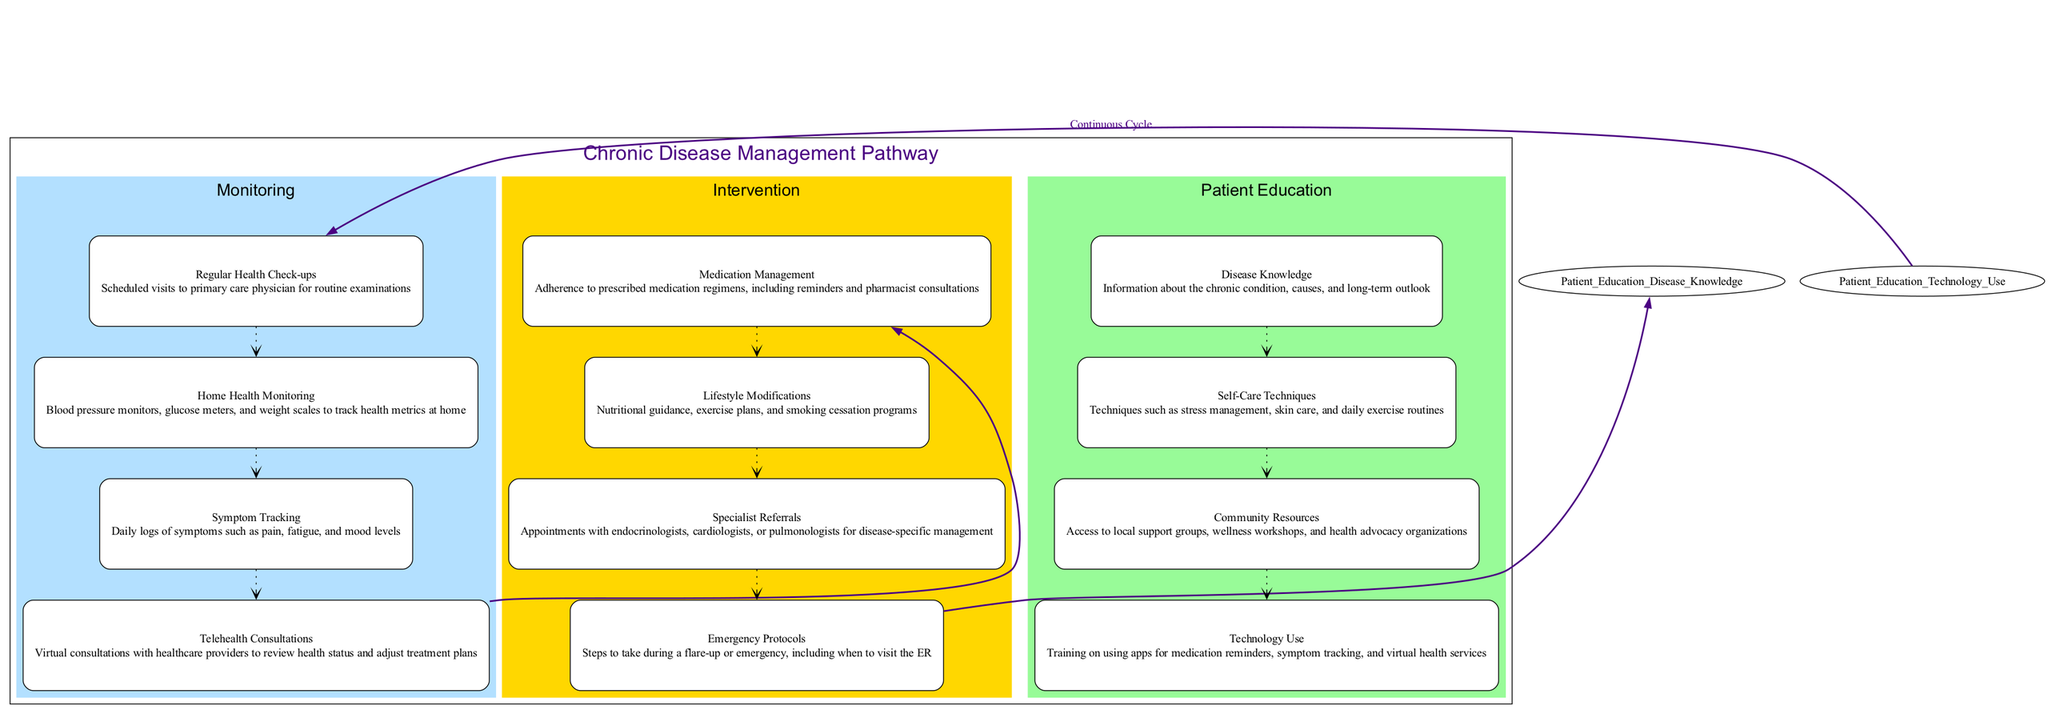What are the four main categories in the pathway? The diagram features three main categories outlined in different colors: Monitoring, Intervention, and Patient Education.
Answer: Monitoring, Intervention, Patient Education How many nodes are in the 'Monitoring' category? There are four specific nodes listed under the Monitoring category: Regular Health Check-ups, Home Health Monitoring, Symptom Tracking, and Telehealth Consultations.
Answer: 4 What is the last node in the 'Intervention' category? The last node in the Intervention category is Emergency Protocols, as arranged in the flow of the diagram.
Answer: Emergency Protocols Which intervention follows Telehealth Consultations? In the progression of the diagram, the next intervention after Telehealth Consultations is Medication Management.
Answer: Medication Management What connects Emergency Protocols and Disease Knowledge? According to the arrows in the diagram, Emergency Protocols directly connect to Disease Knowledge, indicating a flow of information between the two nodes.
Answer: Disease Knowledge Which node represents a continuous cycle back to Monitoring? Technology Use links back to the Monitoring category, representing a continuous cycle in chronic disease management.
Answer: Technology Use How many types of intervention are there? There are four distinct types of interventions listed: Medication Management, Lifestyle Modifications, Specialist Referrals, and Emergency Protocols.
Answer: 4 What is the purpose of Specialist Referrals? The purpose of Specialist Referrals is to secure appointments with specialists like endocrinologists or cardiologists for specific disease management.
Answer: Appointments with specialists Which node contains information about local support groups? The Community Resources node provides information on accessing local support groups, wellness workshops, and health advocacy organizations.
Answer: Community Resources 